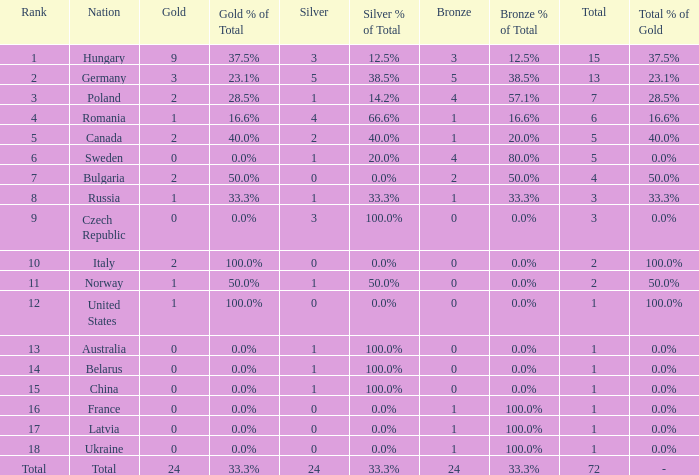How many golds have 3 as the rank, with a total greater than 7? 0.0. 